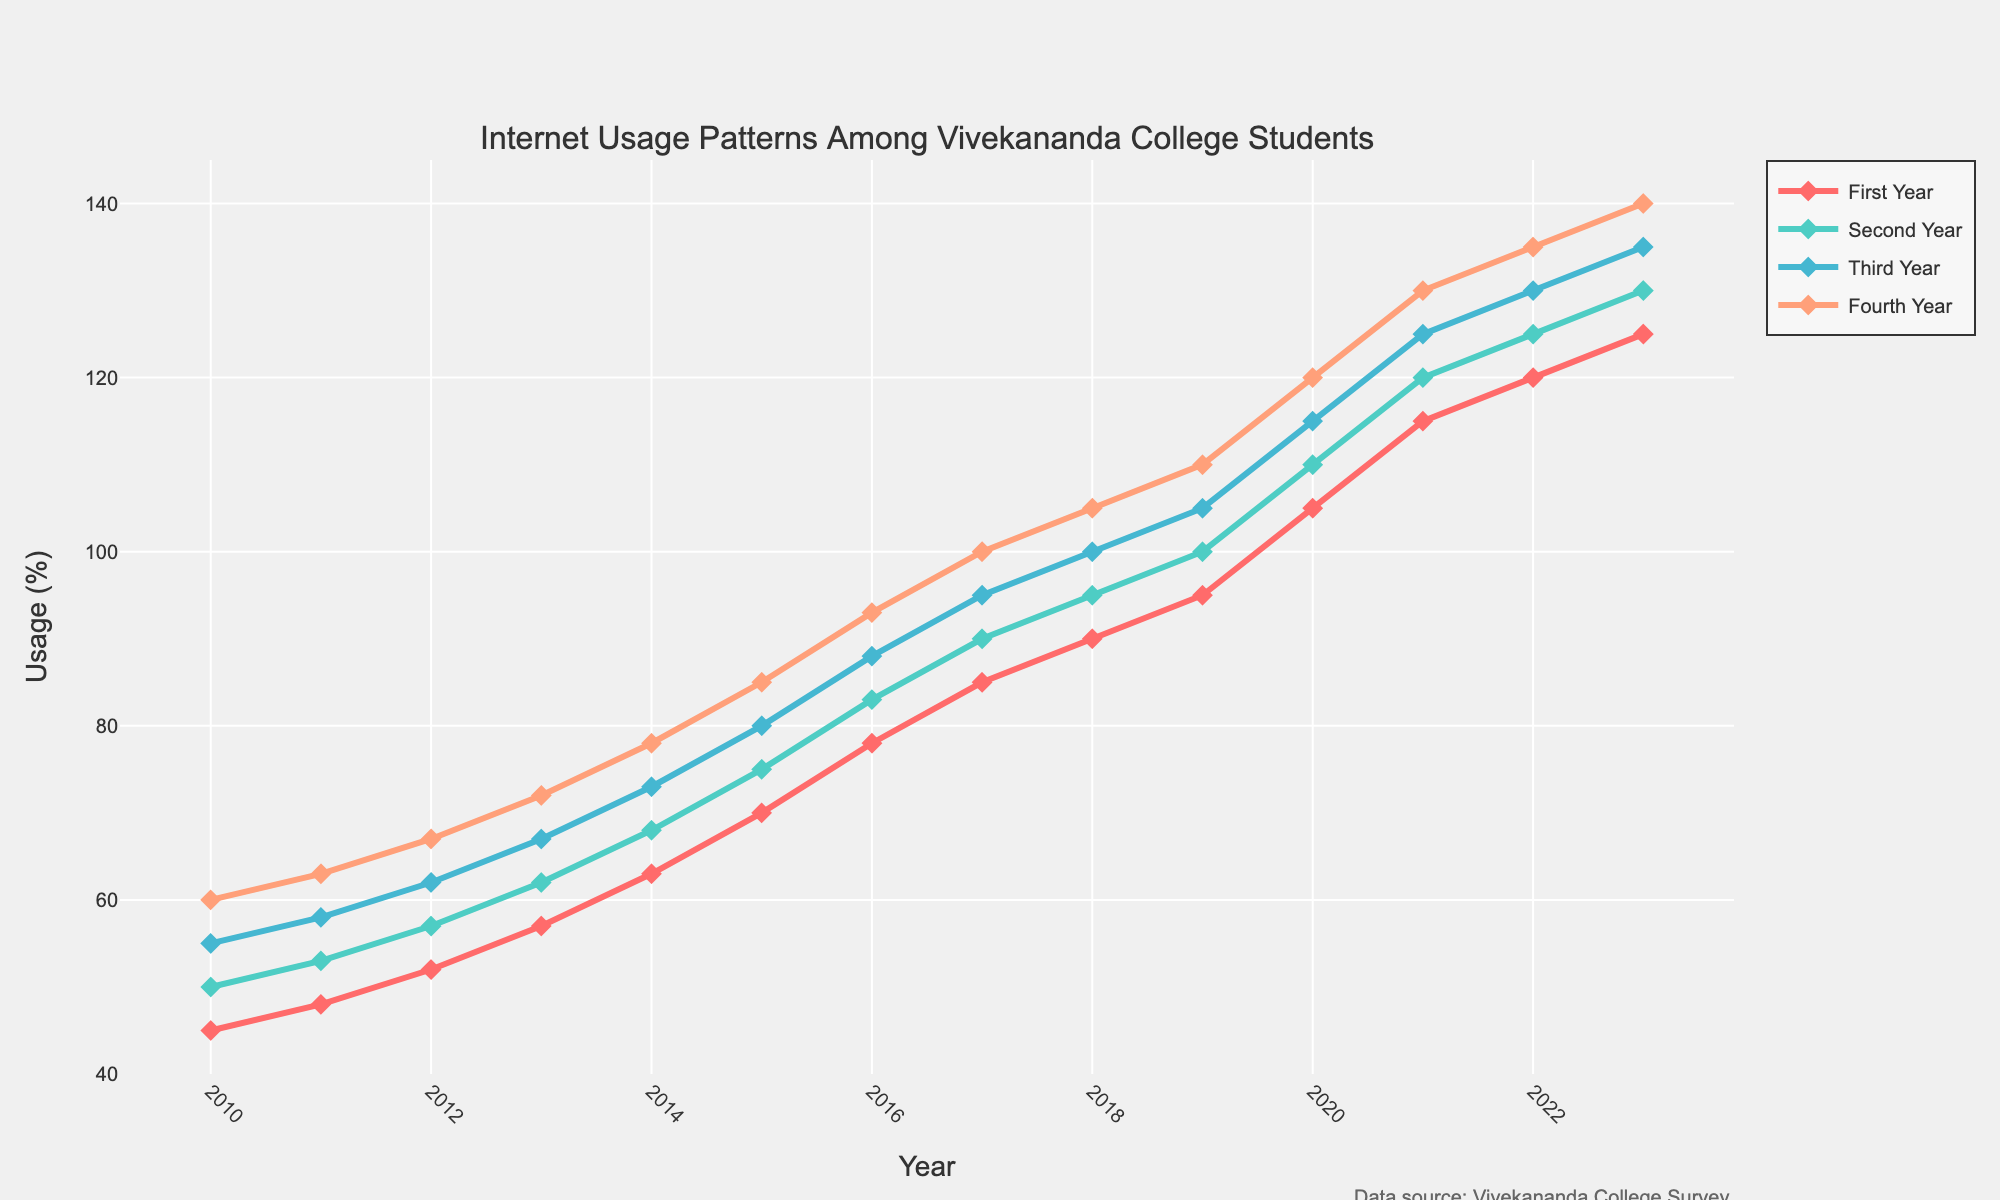What year shows the highest Internet usage for Fourth Year students? By examining the plot, check the Internet usage values for Fourth Year students across all years and identify the highest.
Answer: 2023 Between 2010 and 2023, how has the Internet usage trend changed for First Year students? Observe the line representing First Year students from 2010 to 2023. Note the general direction of the line, whether it is increasing, decreasing, or fluctuating.
Answer: Increased In which year did Second Year and Third Year students have equal Internet usage? Look at the points for Second Year and Third Year students and find the year where the values match.
Answer: 2014 What is the average Internet usage of Third Year students from 2010 to 2023? Sum the usage percentage values for Third Year students from 2010 to 2023 and divide by the number of years (14 years). (55+58+62+67+73+80+88+95+100+105+115+125+130+135)/14 = 95
Answer: 95 Comparing First Year and Fourth Year students, who had more Internet usage in 2015? Identify and compare the usage values for First Year and Fourth Year students in 2015.
Answer: Fourth Year students What's the cumulative Internet usage for Fourth Year students from 2010 to 2013? Add up the Internet usage values for Fourth Year students from 2010 to 2013. (60+63+67+72)
Answer: 262 Which academic year has the steepest increase in Internet usage from 2010 to 2018? Examine the steepness of the lines between each pair of consecutive years for all academic years and pick the one with the largest difference in values from 2010 to 2018.
Answer: Fourth Year Estimate the difference in Internet usage between First Year and Second Year students in 2023. Subtract the value of First Year students from Second Year students in 2023. (130-125)
Answer: 5 From 2010 to 2023, during which year did Internet usage in Third Year students surpass 100%? Search for the year on the plot where the Third Year line crosses 100%.
Answer: 2018 